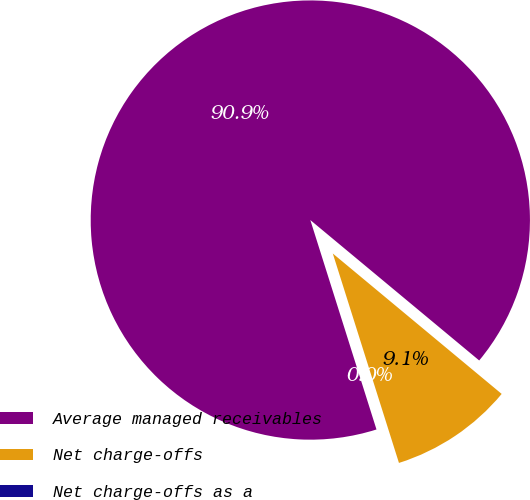Convert chart. <chart><loc_0><loc_0><loc_500><loc_500><pie_chart><fcel>Average managed receivables<fcel>Net charge-offs<fcel>Net charge-offs as a<nl><fcel>90.91%<fcel>9.09%<fcel>0.0%<nl></chart> 